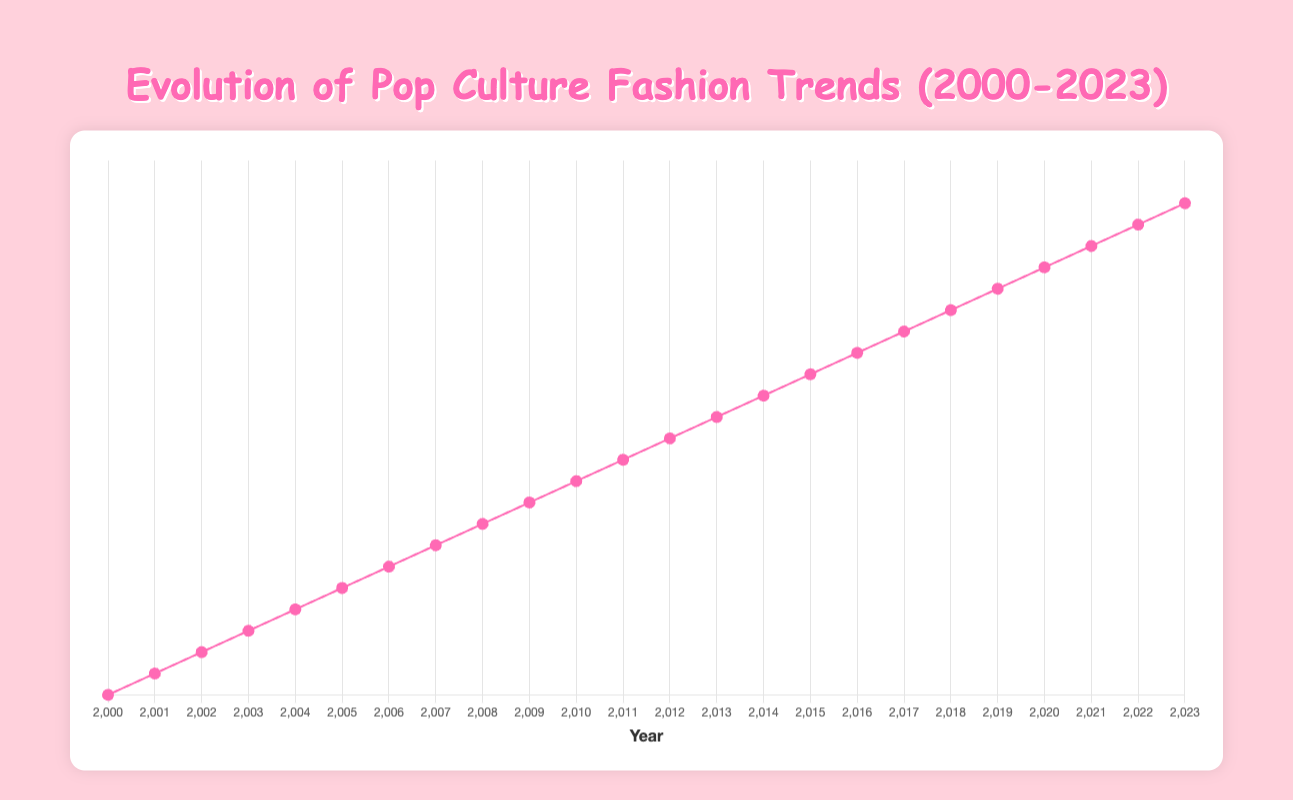What trend influenced by Miley Cyrus became popular in 2007? Refer to the year 2007 in the chart. The trend listed for that year is "Hannah Montana Style" and the influencer is Miley Cyrus.
Answer: Hannah Montana Style Which celebrity influenced the fashion trend in 2023? Look at the information for the year 2023 in the chart. The influencer listed for that year is Harry Styles.
Answer: Harry Styles What was the dominant fashion trend in 2014, and who influenced it? Find the year 2014 on the chart. The trend and influencer listed for that year are "Athleisure" and Kendall Jenner respectively.
Answer: Athleisure, Kendall Jenner How many years after the introduction of Skinny Jeans (2005) did Athleisure become popular? Determine the years for Skinny Jeans (2005) and Athleisure (2014). The difference between these years is 2014 - 2005 = 9 years.
Answer: 9 years Which trend was popularised by Lady Gaga and when did it occur? Locate the trend influenced by Lady Gaga on the chart. The corresponding year is 2009 with the trend "Statement Jewelry."
Answer: 2009, Statement Jewelry Compare the trends from 2000 and 2022. How are they similar? Look at the trends for 2000 (“Y2K Aesthetic”) and 2022 (“Y2K Revival”). Both trends draw inspiration from the early 2000s with bright colors and fun accessories.
Answer: Both are inspired by early 2000s fashion Which trend became popular the year after "Punk Fashion" in 2013? Check the chart for the trend listed in the year following 2013 (i.e., 2014). The trend is "Athleisure."
Answer: Athleisure What is the relationship between the popularity of "Low-Rise Jeans" in 2002 and "High-Waisted Jeans" in 2008? Compare the trends for 2002 and 2008. Low-Rise Jeans were popular in 2002, and High-Waisted Jeans, which are the opposite style, became popular in 2008.
Answer: They are opposite styles Which fashion trend had an influencer known for a famous alter-ego character? Check the influencers for all trends; Miley Cyrus, known for her alter-ego character Hannah Montana, influenced the "Hannah Montana Style" in 2007.
Answer: Hannah Montana Style (2007) 